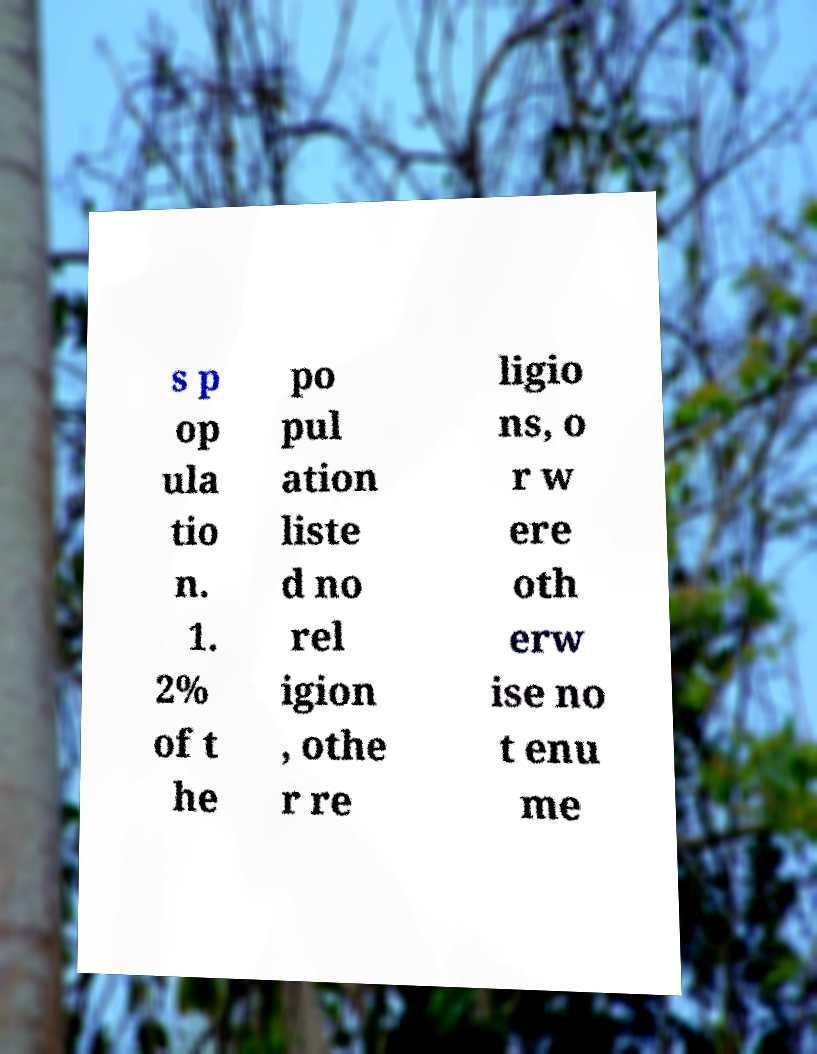Please identify and transcribe the text found in this image. s p op ula tio n. 1. 2% of t he po pul ation liste d no rel igion , othe r re ligio ns, o r w ere oth erw ise no t enu me 